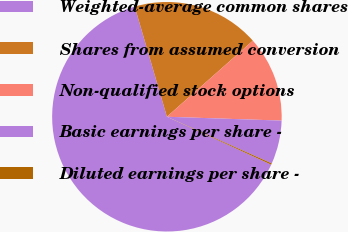<chart> <loc_0><loc_0><loc_500><loc_500><pie_chart><fcel>Weighted-average common shares<fcel>Shares from assumed conversion<fcel>Non-qualified stock options<fcel>Basic earnings per share -<fcel>Diluted earnings per share -<nl><fcel>63.61%<fcel>18.0%<fcel>12.06%<fcel>6.13%<fcel>0.19%<nl></chart> 